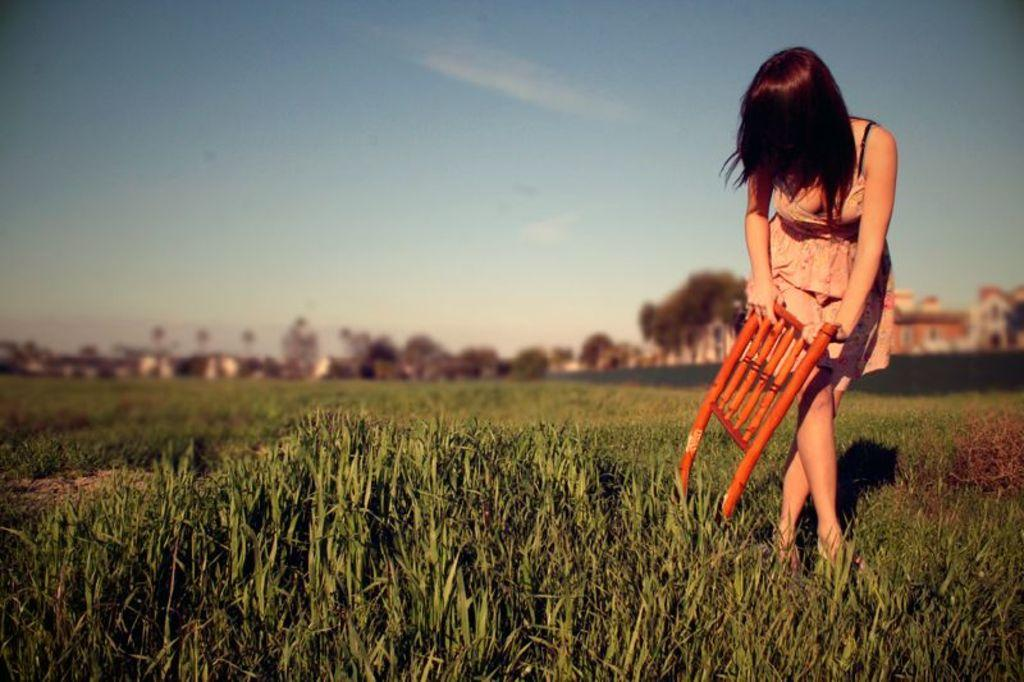Who is the main subject in the image? There is a woman in the image. What is the woman holding in her hand? The woman is holding an object in her hand. What can be seen in the background of the image? There is a group of trees, buildings, and the sky visible in the background of the image. What type of record can be seen on the ground in the image? There is no record present in the image; it features a woman holding an object and a background with trees, buildings, and the sky. 